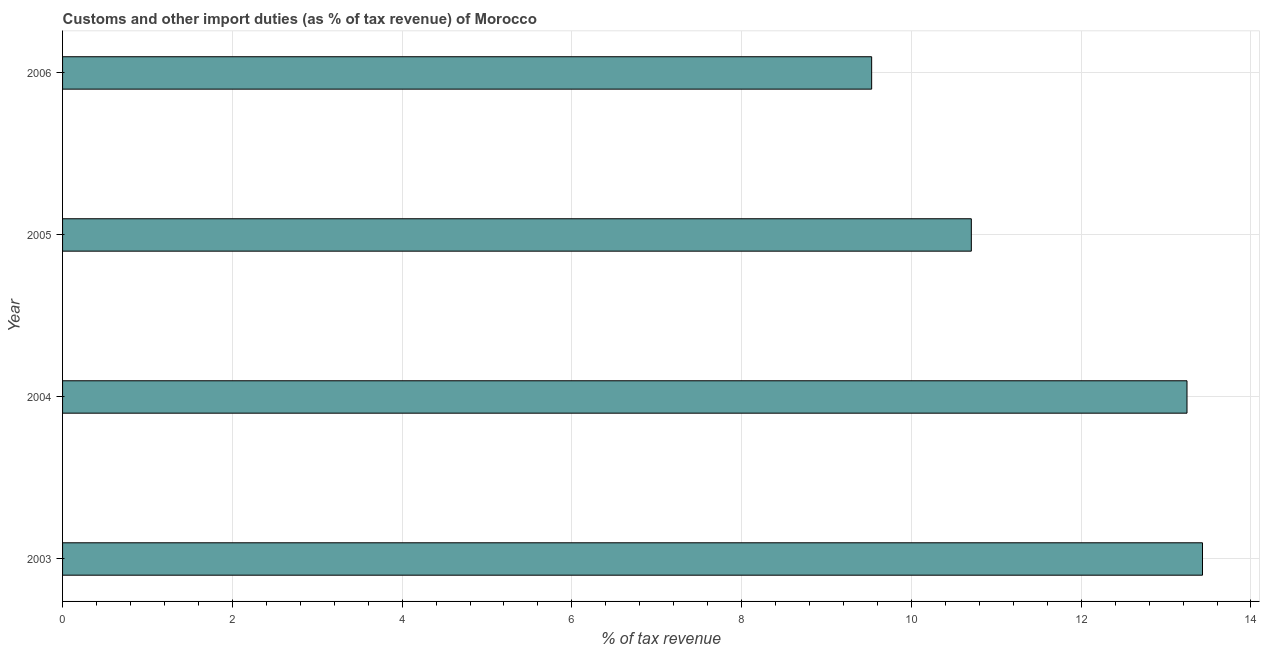What is the title of the graph?
Ensure brevity in your answer.  Customs and other import duties (as % of tax revenue) of Morocco. What is the label or title of the X-axis?
Your answer should be very brief. % of tax revenue. What is the label or title of the Y-axis?
Give a very brief answer. Year. What is the customs and other import duties in 2005?
Provide a short and direct response. 10.71. Across all years, what is the maximum customs and other import duties?
Give a very brief answer. 13.43. Across all years, what is the minimum customs and other import duties?
Your answer should be compact. 9.53. What is the sum of the customs and other import duties?
Make the answer very short. 46.91. What is the difference between the customs and other import duties in 2003 and 2005?
Give a very brief answer. 2.72. What is the average customs and other import duties per year?
Offer a very short reply. 11.73. What is the median customs and other import duties?
Make the answer very short. 11.98. What is the ratio of the customs and other import duties in 2004 to that in 2005?
Provide a succinct answer. 1.24. Is the customs and other import duties in 2004 less than that in 2006?
Offer a terse response. No. What is the difference between the highest and the second highest customs and other import duties?
Your response must be concise. 0.18. Is the sum of the customs and other import duties in 2003 and 2006 greater than the maximum customs and other import duties across all years?
Give a very brief answer. Yes. In how many years, is the customs and other import duties greater than the average customs and other import duties taken over all years?
Offer a terse response. 2. How many bars are there?
Make the answer very short. 4. How many years are there in the graph?
Offer a very short reply. 4. Are the values on the major ticks of X-axis written in scientific E-notation?
Offer a very short reply. No. What is the % of tax revenue of 2003?
Keep it short and to the point. 13.43. What is the % of tax revenue in 2004?
Provide a short and direct response. 13.25. What is the % of tax revenue of 2005?
Keep it short and to the point. 10.71. What is the % of tax revenue of 2006?
Keep it short and to the point. 9.53. What is the difference between the % of tax revenue in 2003 and 2004?
Keep it short and to the point. 0.18. What is the difference between the % of tax revenue in 2003 and 2005?
Offer a terse response. 2.72. What is the difference between the % of tax revenue in 2003 and 2006?
Your answer should be compact. 3.9. What is the difference between the % of tax revenue in 2004 and 2005?
Ensure brevity in your answer.  2.54. What is the difference between the % of tax revenue in 2004 and 2006?
Provide a short and direct response. 3.71. What is the difference between the % of tax revenue in 2005 and 2006?
Provide a short and direct response. 1.17. What is the ratio of the % of tax revenue in 2003 to that in 2004?
Provide a succinct answer. 1.01. What is the ratio of the % of tax revenue in 2003 to that in 2005?
Make the answer very short. 1.25. What is the ratio of the % of tax revenue in 2003 to that in 2006?
Provide a short and direct response. 1.41. What is the ratio of the % of tax revenue in 2004 to that in 2005?
Your response must be concise. 1.24. What is the ratio of the % of tax revenue in 2004 to that in 2006?
Provide a succinct answer. 1.39. What is the ratio of the % of tax revenue in 2005 to that in 2006?
Your answer should be compact. 1.12. 